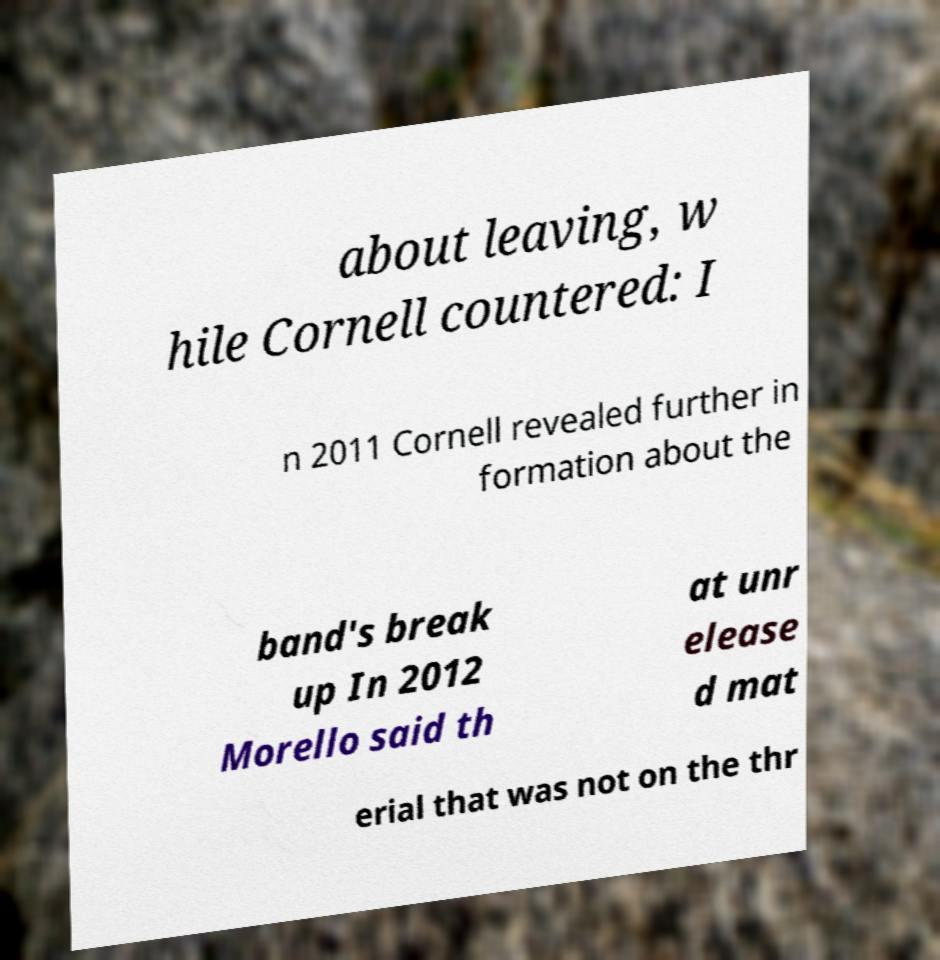There's text embedded in this image that I need extracted. Can you transcribe it verbatim? about leaving, w hile Cornell countered: I n 2011 Cornell revealed further in formation about the band's break up In 2012 Morello said th at unr elease d mat erial that was not on the thr 